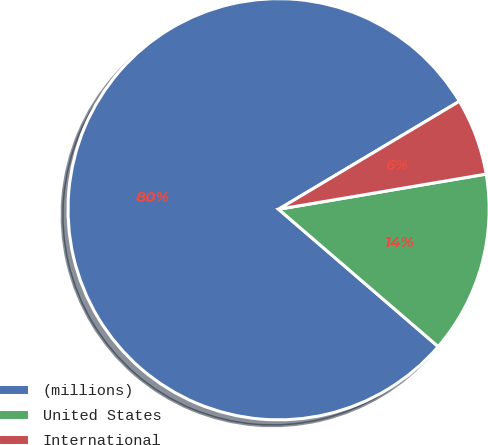<chart> <loc_0><loc_0><loc_500><loc_500><pie_chart><fcel>(millions)<fcel>United States<fcel>International<nl><fcel>80.12%<fcel>13.98%<fcel>5.9%<nl></chart> 